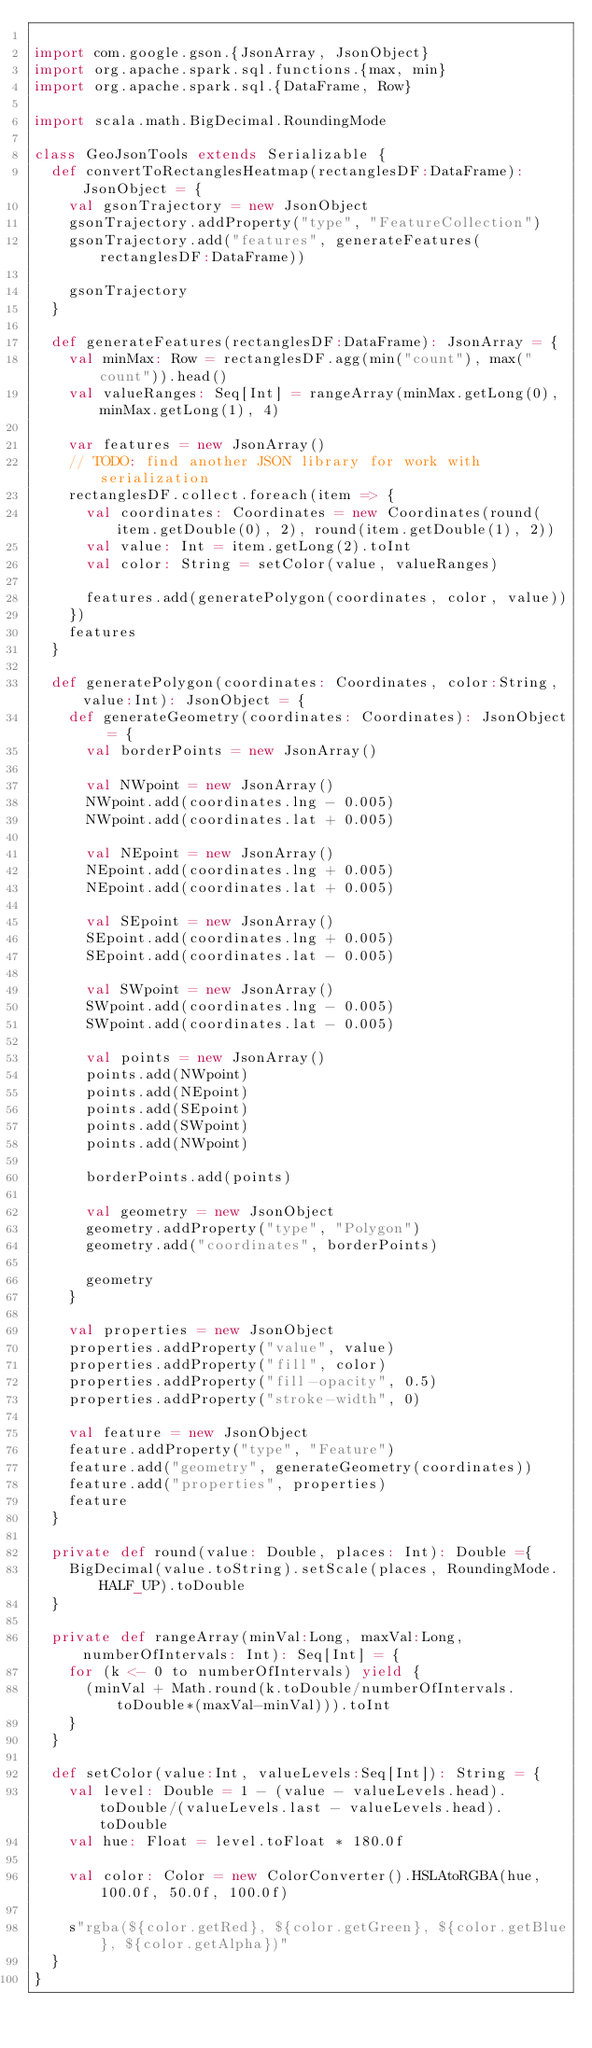Convert code to text. <code><loc_0><loc_0><loc_500><loc_500><_Scala_>
import com.google.gson.{JsonArray, JsonObject}
import org.apache.spark.sql.functions.{max, min}
import org.apache.spark.sql.{DataFrame, Row}

import scala.math.BigDecimal.RoundingMode

class GeoJsonTools extends Serializable {
  def convertToRectanglesHeatmap(rectanglesDF:DataFrame): JsonObject = {
    val gsonTrajectory = new JsonObject
    gsonTrajectory.addProperty("type", "FeatureCollection")
    gsonTrajectory.add("features", generateFeatures(rectanglesDF:DataFrame))

    gsonTrajectory
  }

  def generateFeatures(rectanglesDF:DataFrame): JsonArray = {
    val minMax: Row = rectanglesDF.agg(min("count"), max("count")).head()
    val valueRanges: Seq[Int] = rangeArray(minMax.getLong(0), minMax.getLong(1), 4)

    var features = new JsonArray()
    // TODO: find another JSON library for work with serialization
    rectanglesDF.collect.foreach(item => {
      val coordinates: Coordinates = new Coordinates(round(item.getDouble(0), 2), round(item.getDouble(1), 2))
      val value: Int = item.getLong(2).toInt
      val color: String = setColor(value, valueRanges)

      features.add(generatePolygon(coordinates, color, value))
    })
    features
  }

  def generatePolygon(coordinates: Coordinates, color:String, value:Int): JsonObject = {
    def generateGeometry(coordinates: Coordinates): JsonObject = {
      val borderPoints = new JsonArray()

      val NWpoint = new JsonArray()
      NWpoint.add(coordinates.lng - 0.005)
      NWpoint.add(coordinates.lat + 0.005)

      val NEpoint = new JsonArray()
      NEpoint.add(coordinates.lng + 0.005)
      NEpoint.add(coordinates.lat + 0.005)

      val SEpoint = new JsonArray()
      SEpoint.add(coordinates.lng + 0.005)
      SEpoint.add(coordinates.lat - 0.005)

      val SWpoint = new JsonArray()
      SWpoint.add(coordinates.lng - 0.005)
      SWpoint.add(coordinates.lat - 0.005)

      val points = new JsonArray()
      points.add(NWpoint)
      points.add(NEpoint)
      points.add(SEpoint)
      points.add(SWpoint)
      points.add(NWpoint)

      borderPoints.add(points)

      val geometry = new JsonObject
      geometry.addProperty("type", "Polygon")
      geometry.add("coordinates", borderPoints)

      geometry
    }

    val properties = new JsonObject
    properties.addProperty("value", value)
    properties.addProperty("fill", color)
    properties.addProperty("fill-opacity", 0.5)
    properties.addProperty("stroke-width", 0)

    val feature = new JsonObject
    feature.addProperty("type", "Feature")
    feature.add("geometry", generateGeometry(coordinates))
    feature.add("properties", properties)
    feature
  }

  private def round(value: Double, places: Int): Double ={
    BigDecimal(value.toString).setScale(places, RoundingMode.HALF_UP).toDouble
  }

  private def rangeArray(minVal:Long, maxVal:Long, numberOfIntervals: Int): Seq[Int] = {
    for (k <- 0 to numberOfIntervals) yield {
      (minVal + Math.round(k.toDouble/numberOfIntervals.toDouble*(maxVal-minVal))).toInt
    }
  }

  def setColor(value:Int, valueLevels:Seq[Int]): String = {
    val level: Double = 1 - (value - valueLevels.head).toDouble/(valueLevels.last - valueLevels.head).toDouble
    val hue: Float = level.toFloat * 180.0f

    val color: Color = new ColorConverter().HSLAtoRGBA(hue, 100.0f, 50.0f, 100.0f)

    s"rgba(${color.getRed}, ${color.getGreen}, ${color.getBlue}, ${color.getAlpha})"
  }
}
</code> 